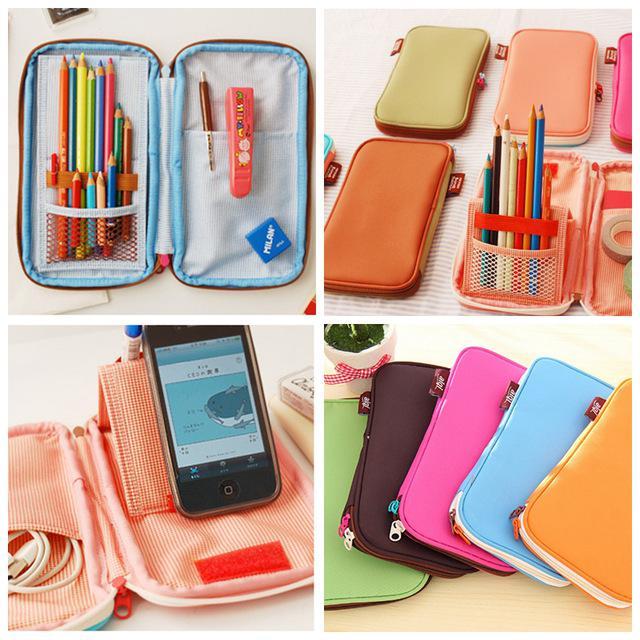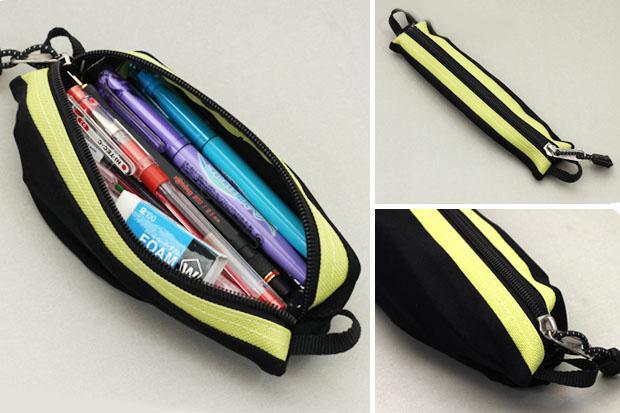The first image is the image on the left, the second image is the image on the right. Examine the images to the left and right. Is the description "Each image contains an open turquoise blue pencil box." accurate? Answer yes or no. No. 